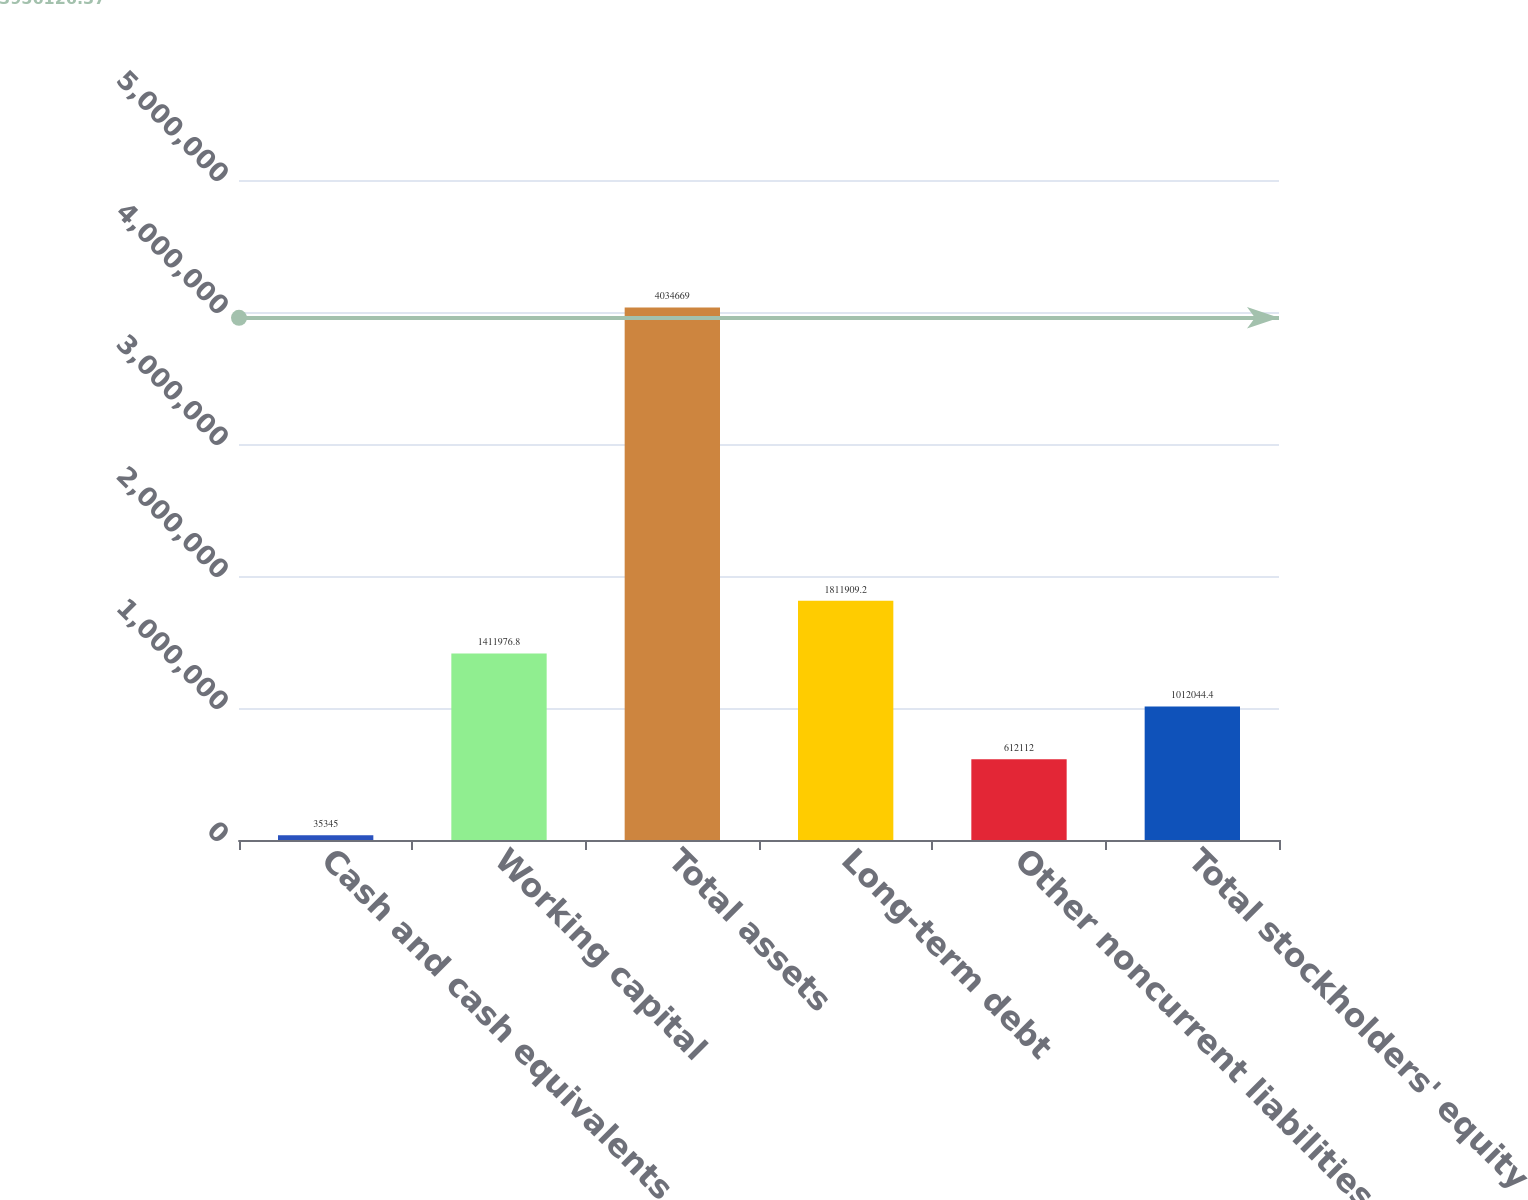Convert chart. <chart><loc_0><loc_0><loc_500><loc_500><bar_chart><fcel>Cash and cash equivalents<fcel>Working capital<fcel>Total assets<fcel>Long-term debt<fcel>Other noncurrent liabilities<fcel>Total stockholders' equity<nl><fcel>35345<fcel>1.41198e+06<fcel>4.03467e+06<fcel>1.81191e+06<fcel>612112<fcel>1.01204e+06<nl></chart> 